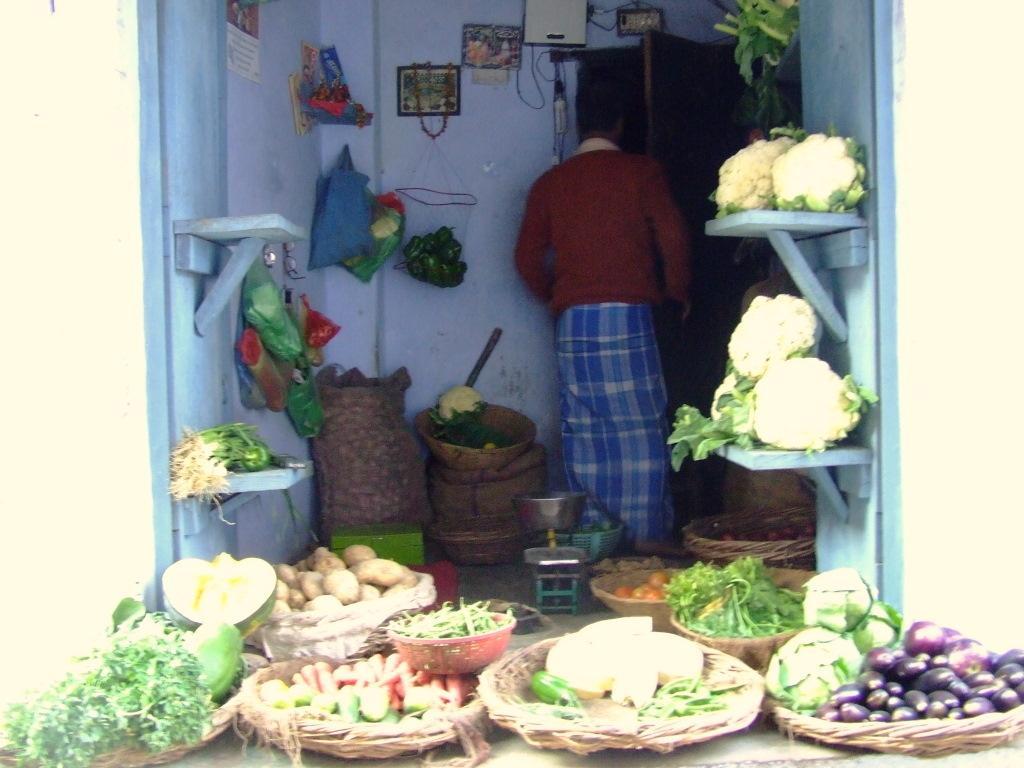Describe this image in one or two sentences. This image is of a vegetable stall. There are vegetables in baskets. There is a person standing. There is wall. There are photo frames on the wall. 